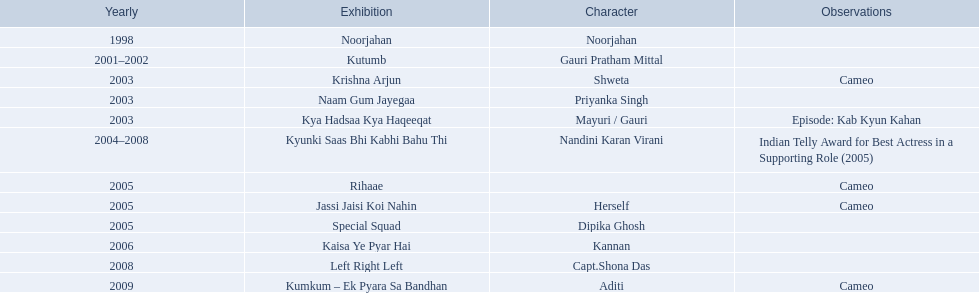What are all of the shows? Noorjahan, Kutumb, Krishna Arjun, Naam Gum Jayegaa, Kya Hadsaa Kya Haqeeqat, Kyunki Saas Bhi Kabhi Bahu Thi, Rihaae, Jassi Jaisi Koi Nahin, Special Squad, Kaisa Ye Pyar Hai, Left Right Left, Kumkum – Ek Pyara Sa Bandhan. When did they premiere? 1998, 2001–2002, 2003, 2003, 2003, 2004–2008, 2005, 2005, 2005, 2006, 2008, 2009. What notes are there for the shows from 2005? Cameo, Cameo. Along with rihaee, what is the other show gauri had a cameo role in? Jassi Jaisi Koi Nahin. 